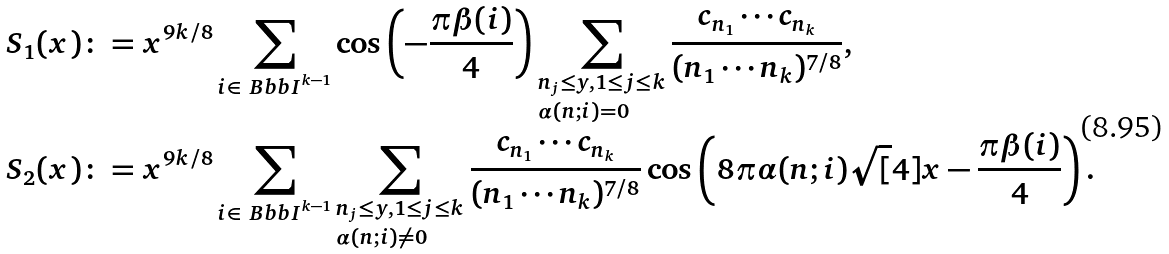<formula> <loc_0><loc_0><loc_500><loc_500>S _ { 1 } ( x ) \colon & = x ^ { 9 k / 8 } \sum _ { i \in { \ B b b I } ^ { k - 1 } } \cos \left ( - \frac { \pi \beta ( i ) } { 4 } \right ) \sum _ { \begin{subarray} { c } n _ { j } \leq y , 1 \leq j \leq k \\ \alpha ( n ; i ) = 0 \end{subarray} } \frac { c _ { n _ { 1 } } \cdots c _ { n _ { k } } } { ( n _ { 1 } \cdots n _ { k } ) ^ { 7 / 8 } } , \\ S _ { 2 } ( x ) \colon & = x ^ { 9 k / 8 } \sum _ { i \in { \ B b b I } ^ { k - 1 } } \sum _ { \begin{subarray} { c } n _ { j } \leq y , 1 \leq j \leq k \\ \alpha ( n ; i ) \not = 0 \end{subarray} } \frac { c _ { n _ { 1 } } \cdots c _ { n _ { k } } } { ( n _ { 1 } \cdots n _ { k } ) ^ { 7 / 8 } } \cos \left ( 8 \pi \alpha ( n ; i ) \sqrt { [ } 4 ] x - \frac { \pi \beta ( i ) } { 4 } \right ) .</formula> 